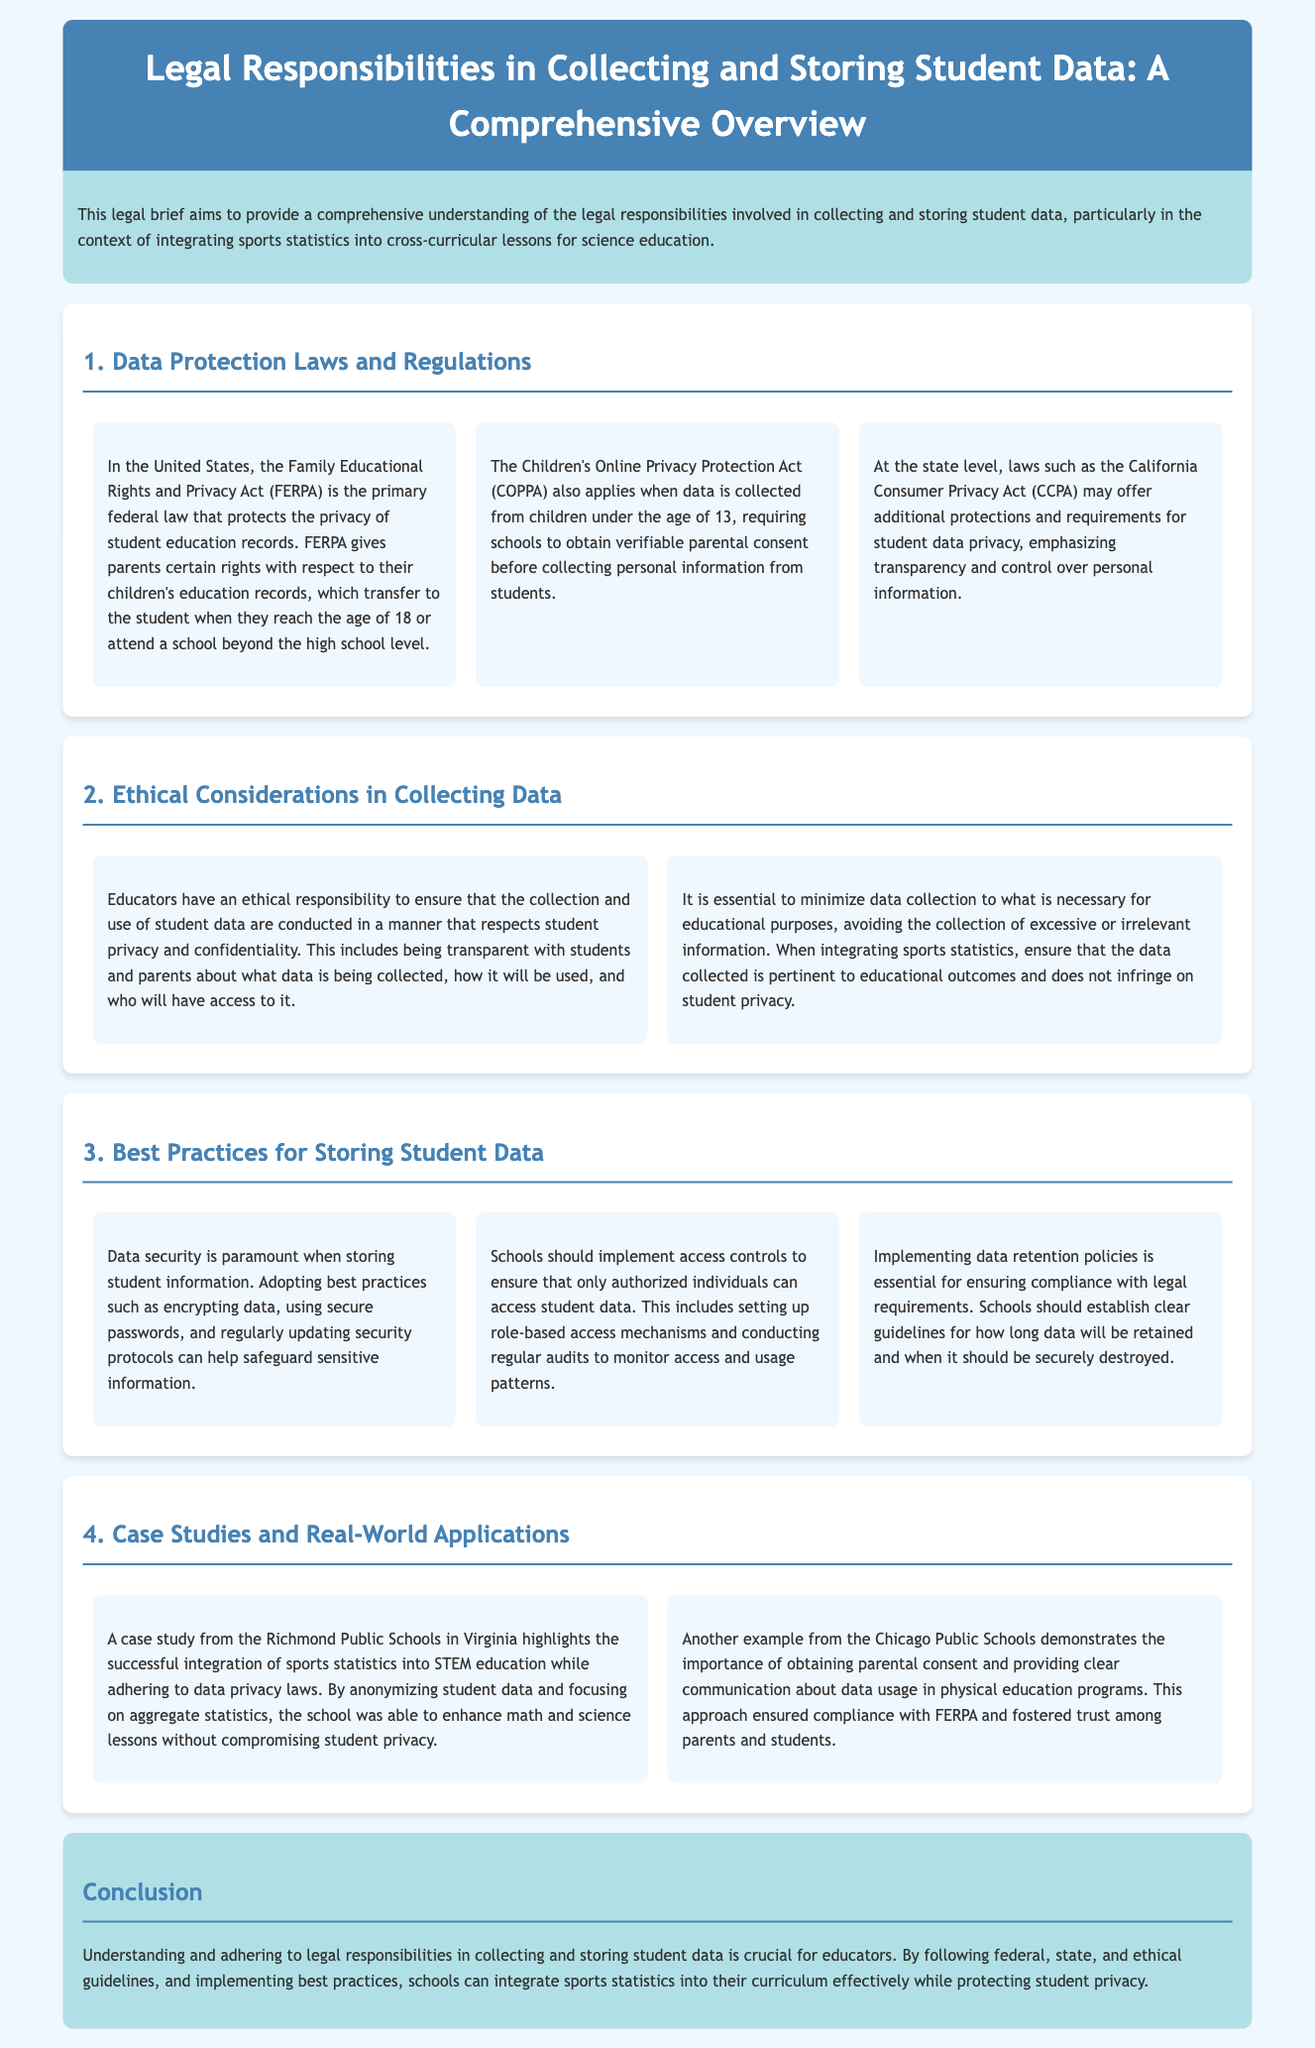What is the primary federal law protecting student education records? The document states that the Family Educational Rights and Privacy Act (FERPA) is the primary federal law that protects the privacy of student education records.
Answer: FERPA What age do parental rights transfer to students under FERPA? The document mentions that rights transfer to the student when they reach the age of 18.
Answer: 18 Which act requires parental consent for data collection from children under 13? The document identifies the Children's Online Privacy Protection Act (COPPA) as requiring verifiable parental consent.
Answer: COPPA What is a best practice for data security when storing student information? The document states that adopting best practices such as encrypting data is a crucial measure for data security.
Answer: Encrypting data Which California law offers additional protections for student data privacy? The document refers to the California Consumer Privacy Act (CCPA) as offering additional protections and requirements.
Answer: CCPA What ethical responsibility do educators have regarding data collection? The document asserts that educators have an ethical responsibility to respect student privacy and confidentiality.
Answer: Respect student privacy How did Richmond Public Schools integrate sports statistics into education? According to the document, Richmond Public Schools successfully integrated sports statistics by anonymizing student data.
Answer: Anonymizing student data What should be established for how long data will be retained? The document emphasizes the importance of implementing data retention policies.
Answer: Data retention policies What should schools conduct to monitor access to student data? The document recommends conducting regular audits to monitor access and usage patterns of student data.
Answer: Regular audits 